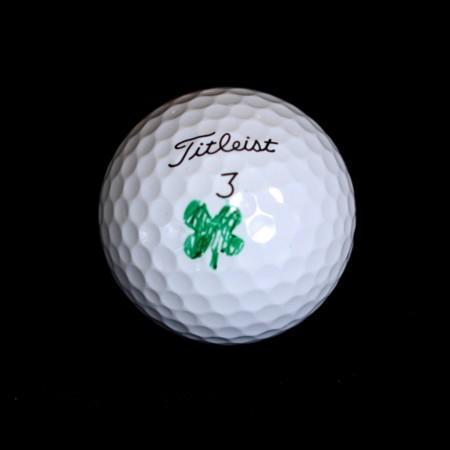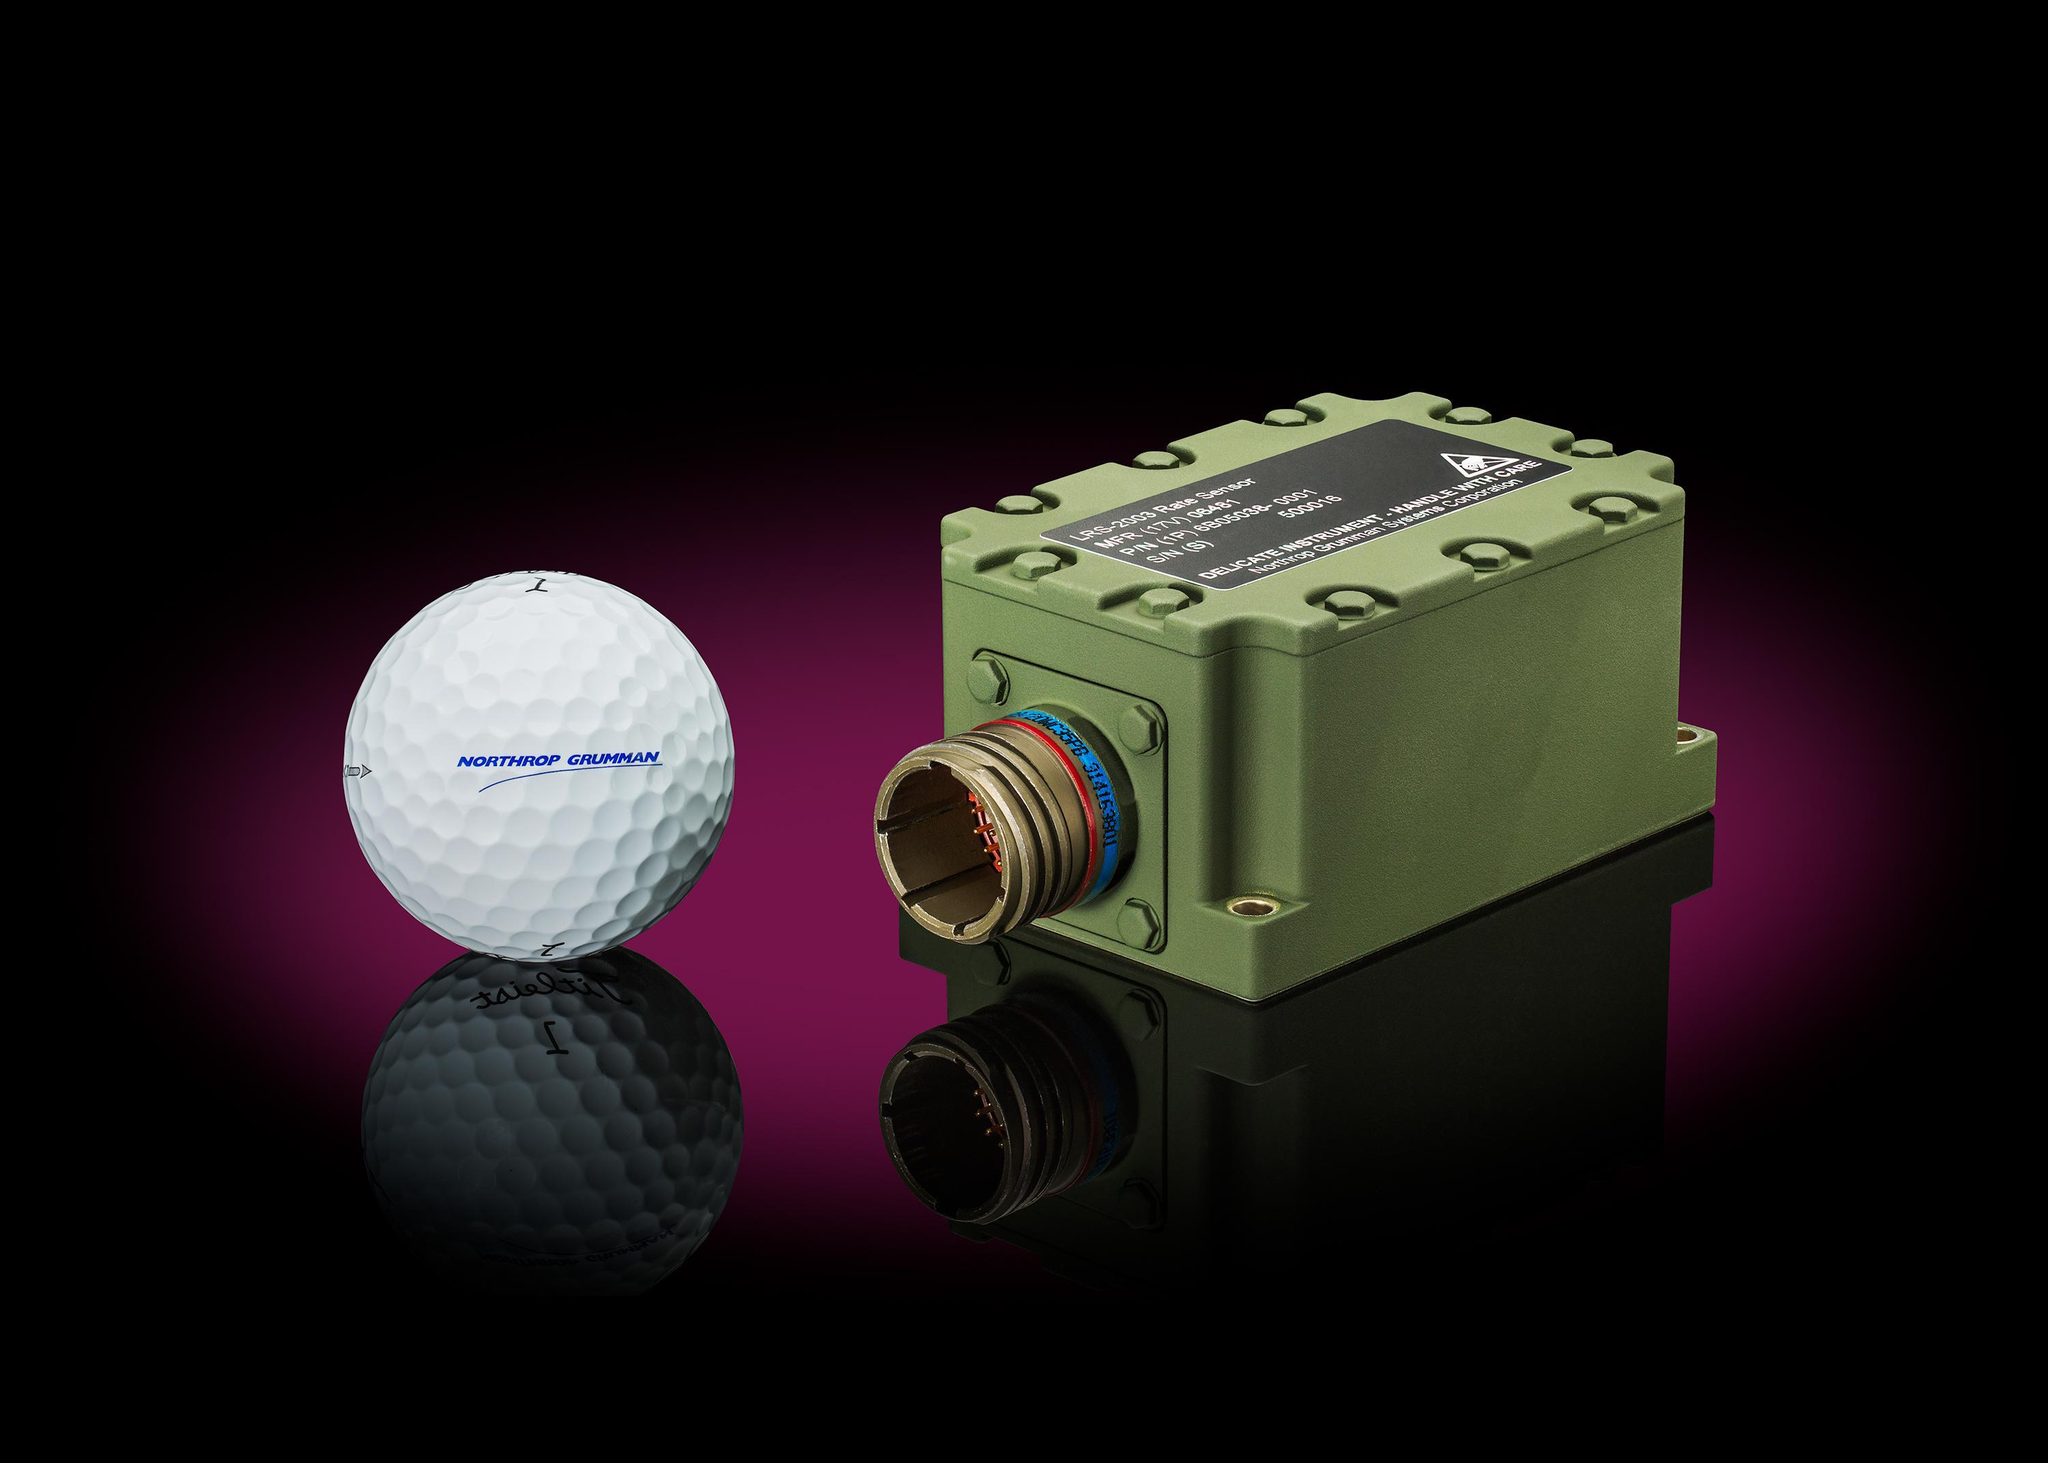The first image is the image on the left, the second image is the image on the right. Analyze the images presented: Is the assertion "Both images show the inside of a golf ball." valid? Answer yes or no. No. The first image is the image on the left, the second image is the image on the right. Evaluate the accuracy of this statement regarding the images: "An image shows at least four interior layers of a white golf ball.". Is it true? Answer yes or no. No. 